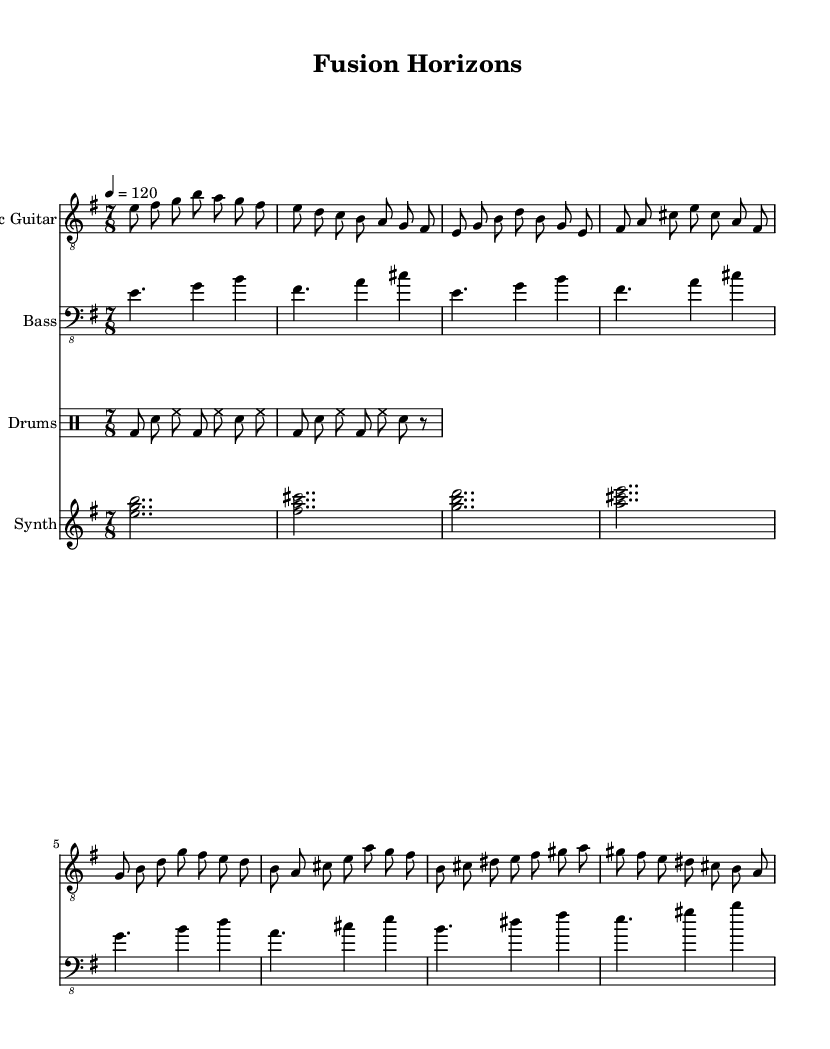What is the key signature of this music? The key signature is defined at the beginning of the score, which shows an E minor key. This indicates the presence of one sharp, F sharp.
Answer: E minor What is the time signature of the piece? The time signature is indicated after the key signature, which shows a division of 7/8. This informs us that there are seven eighth notes in each measure.
Answer: 7/8 What is the tempo marking of the piece? The tempo marking is found near the top of the score, indicating a tempo of 120 beats per minute, which tells us how quickly the music should be played.
Answer: 120 How many measures are in the chorus section? By referring to the music excerpt, we can identify the chorus section spans four measures, as it contains four distinct rhythmic patterns.
Answer: 4 measures What rhythmic feel is primarily used in the drums? The drum part displays a basic pattern featuring a combination of bass and snare hits, primarily maintaining a straight eighth note feel with accents. This typically conveys a strong metal rhythm.
Answer: Eighth notes What differentiates the synth part from the other instruments? The synth part consists of long, sustained chords, providing an atmospheric quality, distinguishing it from the more rhythmically active electric guitar and drums, which have short, articulated notes.
Answer: Chords What is the significance of using a 7/8 time signature in this piece? The 7/8 time signature introduces an unconventional rhythmic feel, which is a hallmark of progressive metal, allowing for more complex and varied musical phrases that can blend seamlessly with jazz fusion elements.
Answer: Unconventional rhythmic feel 